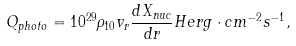<formula> <loc_0><loc_0><loc_500><loc_500>Q _ { p h o t o } = 1 0 ^ { 2 9 } \rho _ { 1 0 } v _ { r } \frac { d X _ { n u c } } { d r } H e r g \cdot c m ^ { - 2 } s ^ { - 1 } ,</formula> 